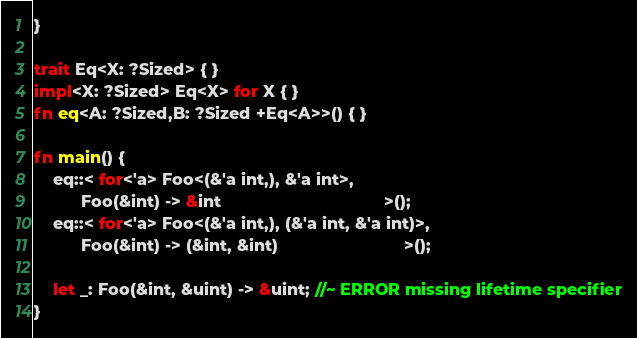<code> <loc_0><loc_0><loc_500><loc_500><_Rust_>}

trait Eq<X: ?Sized> { }
impl<X: ?Sized> Eq<X> for X { }
fn eq<A: ?Sized,B: ?Sized +Eq<A>>() { }

fn main() {
    eq::< for<'a> Foo<(&'a int,), &'a int>,
          Foo(&int) -> &int                                   >();
    eq::< for<'a> Foo<(&'a int,), (&'a int, &'a int)>,
          Foo(&int) -> (&int, &int)                           >();

    let _: Foo(&int, &uint) -> &uint; //~ ERROR missing lifetime specifier
}
</code> 